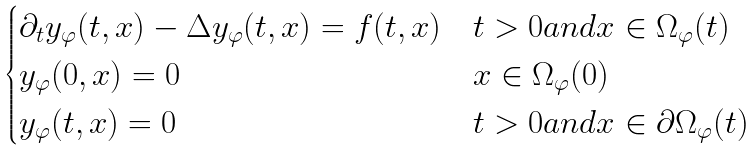Convert formula to latex. <formula><loc_0><loc_0><loc_500><loc_500>\begin{cases} \partial _ { t } y _ { \varphi } ( t , x ) - \Delta y _ { \varphi } ( t , x ) = f ( t , x ) & t > 0 a n d x \in \Omega _ { \varphi } ( t ) \\ y _ { \varphi } ( 0 , x ) = 0 & x \in \Omega _ { \varphi } ( 0 ) \\ y _ { \varphi } ( t , x ) = 0 & t > 0 a n d x \in \partial \Omega _ { \varphi } ( t ) \end{cases}</formula> 